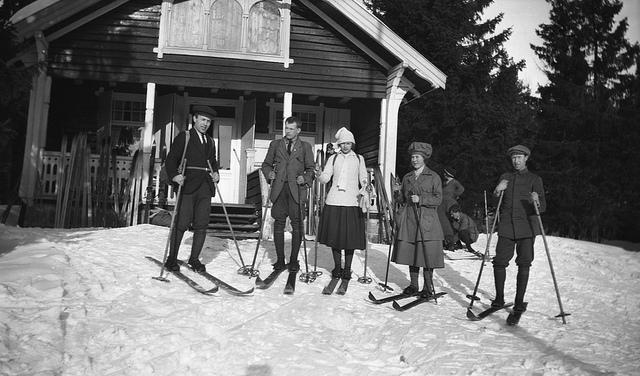How many men are wearing skis?
Give a very brief answer. 3. How many people can be seen?
Give a very brief answer. 5. How many people are holding umbrellas in the photo?
Give a very brief answer. 0. 